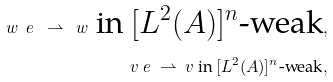<formula> <loc_0><loc_0><loc_500><loc_500>w _ { \ } e \ \rightharpoonup \ w \text { in $[L^{2}(A)]^{n}$-weak} , \\ v _ { \ } e \ \rightharpoonup \ v \text { in $[L^{2}(A)]^{n}$-weak} ,</formula> 